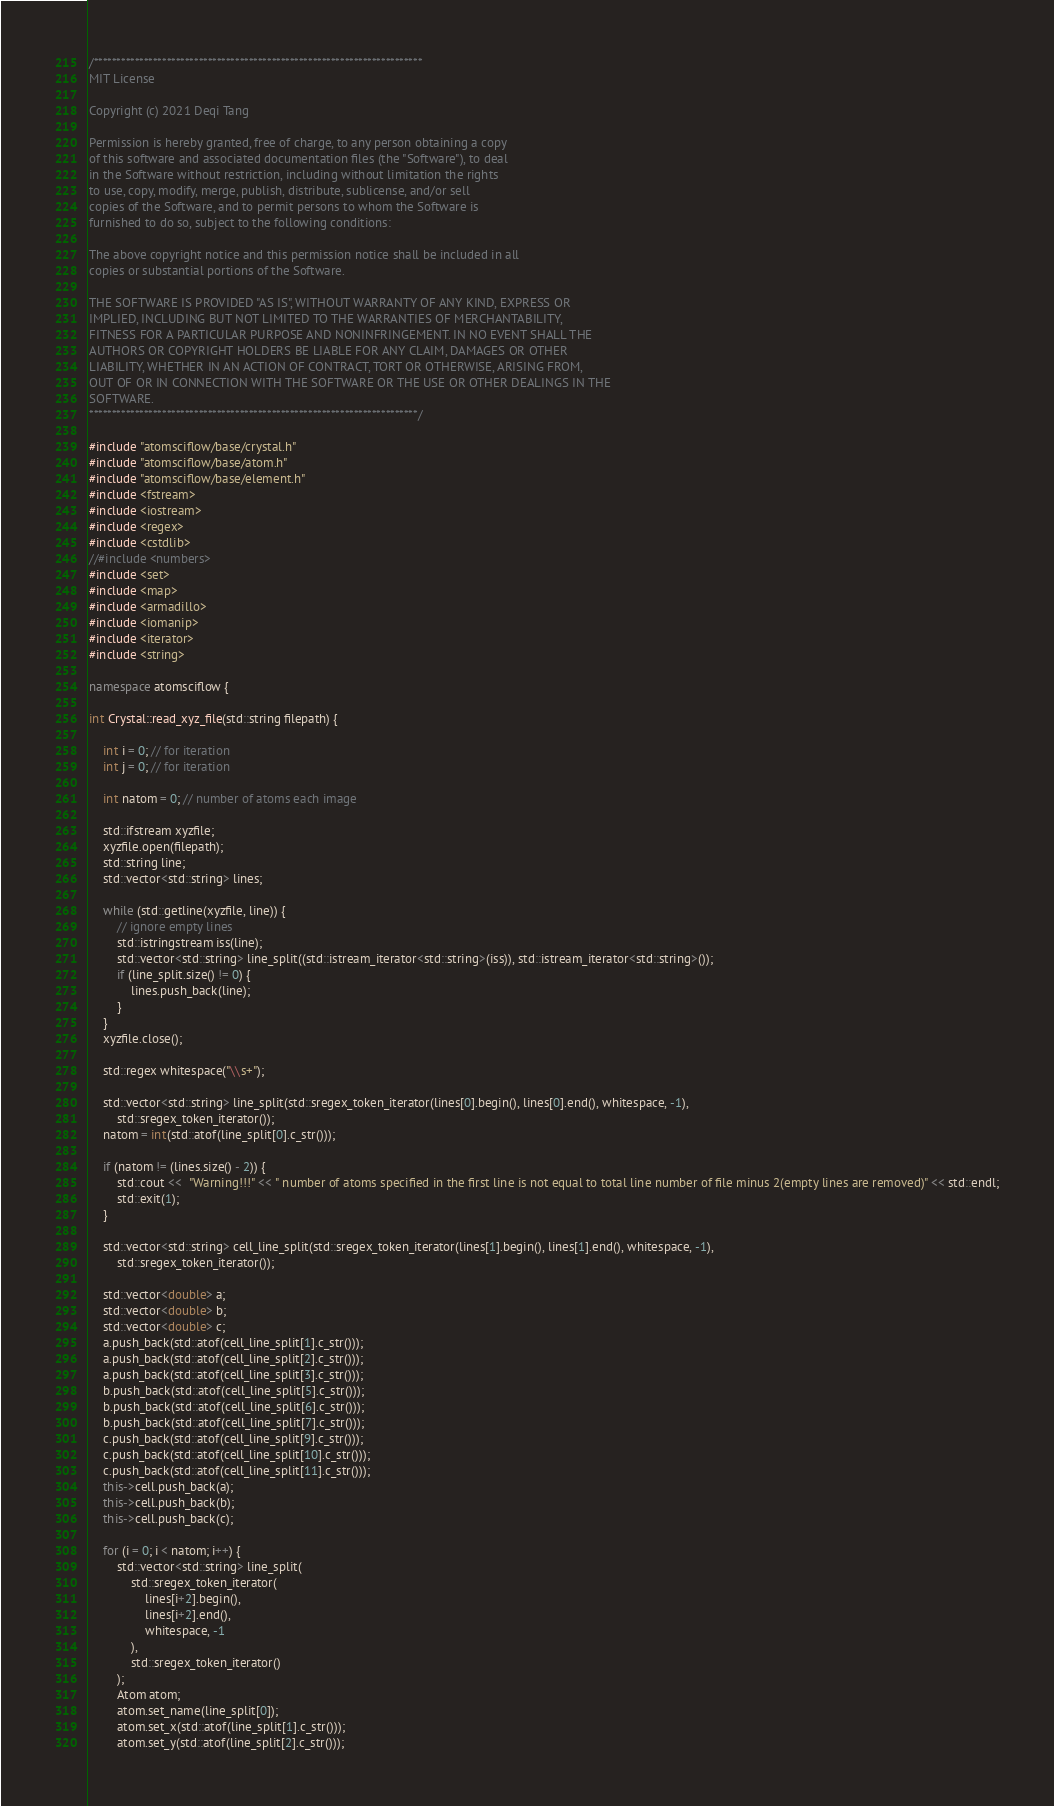<code> <loc_0><loc_0><loc_500><loc_500><_C++_>/************************************************************************
MIT License

Copyright (c) 2021 Deqi Tang

Permission is hereby granted, free of charge, to any person obtaining a copy
of this software and associated documentation files (the "Software"), to deal
in the Software without restriction, including without limitation the rights
to use, copy, modify, merge, publish, distribute, sublicense, and/or sell
copies of the Software, and to permit persons to whom the Software is
furnished to do so, subject to the following conditions:

The above copyright notice and this permission notice shall be included in all
copies or substantial portions of the Software.

THE SOFTWARE IS PROVIDED "AS IS", WITHOUT WARRANTY OF ANY KIND, EXPRESS OR
IMPLIED, INCLUDING BUT NOT LIMITED TO THE WARRANTIES OF MERCHANTABILITY,
FITNESS FOR A PARTICULAR PURPOSE AND NONINFRINGEMENT. IN NO EVENT SHALL THE
AUTHORS OR COPYRIGHT HOLDERS BE LIABLE FOR ANY CLAIM, DAMAGES OR OTHER
LIABILITY, WHETHER IN AN ACTION OF CONTRACT, TORT OR OTHERWISE, ARISING FROM,
OUT OF OR IN CONNECTION WITH THE SOFTWARE OR THE USE OR OTHER DEALINGS IN THE
SOFTWARE.
************************************************************************/

#include "atomsciflow/base/crystal.h"
#include "atomsciflow/base/atom.h"
#include "atomsciflow/base/element.h"
#include <fstream>
#include <iostream>
#include <regex>
#include <cstdlib>
//#include <numbers>
#include <set>
#include <map>
#include <armadillo>
#include <iomanip>
#include <iterator>
#include <string>

namespace atomsciflow {

int Crystal::read_xyz_file(std::string filepath) {
    
    int i = 0; // for iteration
    int j = 0; // for iteration
    
    int natom = 0; // number of atoms each image

    std::ifstream xyzfile;
    xyzfile.open(filepath);
    std::string line;
    std::vector<std::string> lines;

    while (std::getline(xyzfile, line)) {
        // ignore empty lines
        std::istringstream iss(line);
        std::vector<std::string> line_split((std::istream_iterator<std::string>(iss)), std::istream_iterator<std::string>());
        if (line_split.size() != 0) {
            lines.push_back(line);
        }
    }
    xyzfile.close();
    
    std::regex whitespace("\\s+");
    
    std::vector<std::string> line_split(std::sregex_token_iterator(lines[0].begin(), lines[0].end(), whitespace, -1), 
        std::sregex_token_iterator());
    natom = int(std::atof(line_split[0].c_str()));
    
    if (natom != (lines.size() - 2)) {
        std::cout <<  "Warning!!!" << " number of atoms specified in the first line is not equal to total line number of file minus 2(empty lines are removed)" << std::endl;
        std::exit(1);
    }
    
    std::vector<std::string> cell_line_split(std::sregex_token_iterator(lines[1].begin(), lines[1].end(), whitespace, -1), 
        std::sregex_token_iterator());
        
    std::vector<double> a;
    std::vector<double> b;
    std::vector<double> c;
    a.push_back(std::atof(cell_line_split[1].c_str()));
    a.push_back(std::atof(cell_line_split[2].c_str()));
    a.push_back(std::atof(cell_line_split[3].c_str()));
    b.push_back(std::atof(cell_line_split[5].c_str()));
    b.push_back(std::atof(cell_line_split[6].c_str()));
    b.push_back(std::atof(cell_line_split[7].c_str()));
    c.push_back(std::atof(cell_line_split[9].c_str()));
    c.push_back(std::atof(cell_line_split[10].c_str()));
    c.push_back(std::atof(cell_line_split[11].c_str()));
    this->cell.push_back(a);
    this->cell.push_back(b);
    this->cell.push_back(c);        

    for (i = 0; i < natom; i++) {
        std::vector<std::string> line_split(
            std::sregex_token_iterator(
                lines[i+2].begin(),
                lines[i+2].end(),
                whitespace, -1
            ),
            std::sregex_token_iterator()
        );
        Atom atom;
        atom.set_name(line_split[0]);
        atom.set_x(std::atof(line_split[1].c_str()));
        atom.set_y(std::atof(line_split[2].c_str()));</code> 